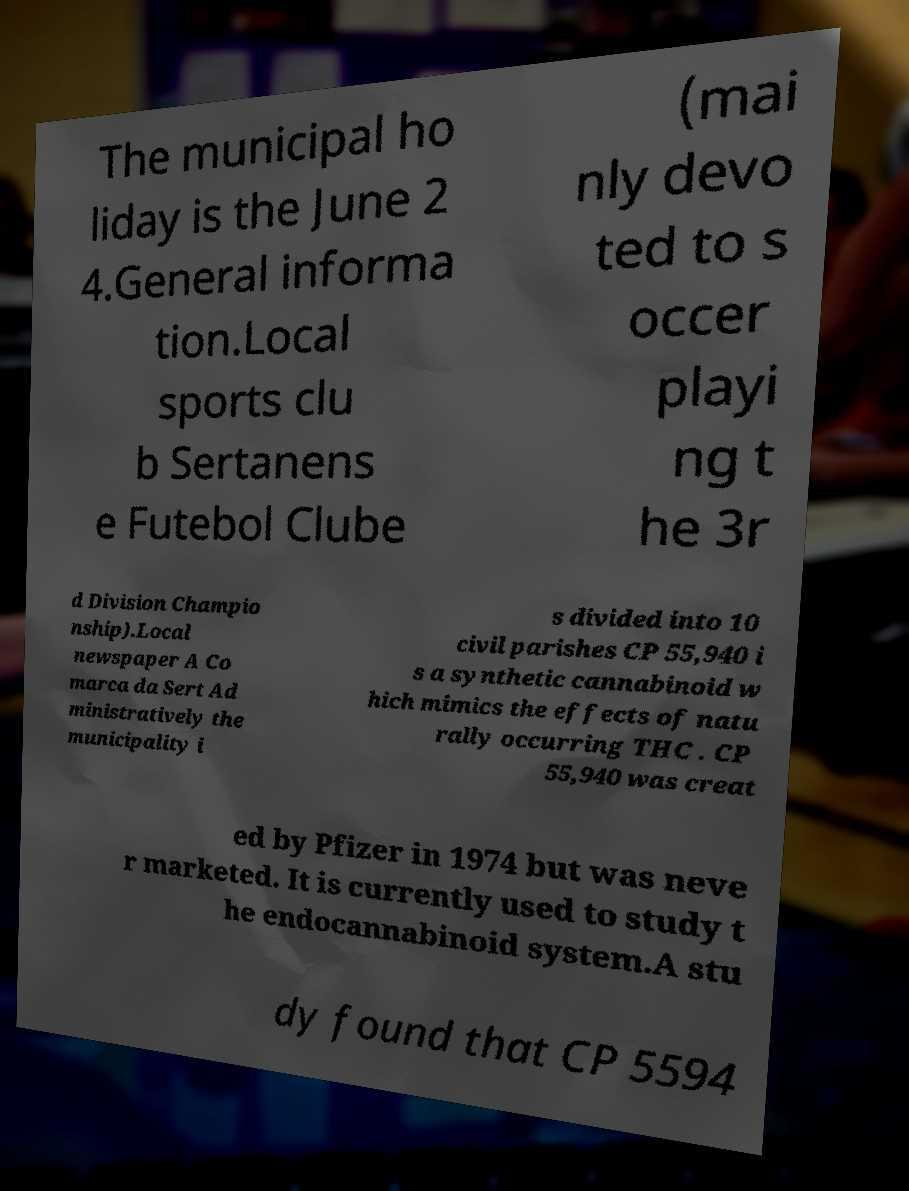What messages or text are displayed in this image? I need them in a readable, typed format. The municipal ho liday is the June 2 4.General informa tion.Local sports clu b Sertanens e Futebol Clube (mai nly devo ted to s occer playi ng t he 3r d Division Champio nship).Local newspaper A Co marca da Sert Ad ministratively the municipality i s divided into 10 civil parishes CP 55,940 i s a synthetic cannabinoid w hich mimics the effects of natu rally occurring THC . CP 55,940 was creat ed by Pfizer in 1974 but was neve r marketed. It is currently used to study t he endocannabinoid system.A stu dy found that CP 5594 